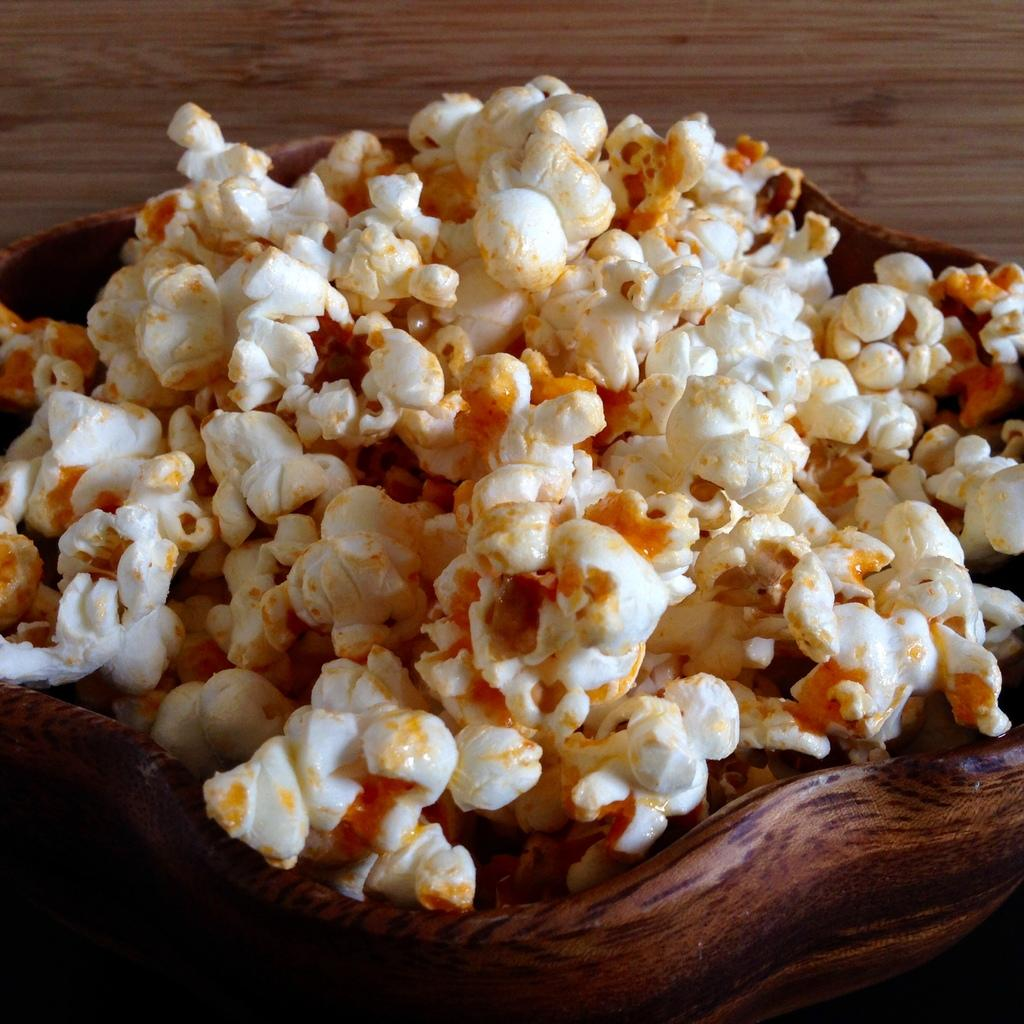What type of food is present in the image? There is popcorn in the image. What is the popcorn contained in? The popcorn is in a wooden bowl. Where is the wooden bowl placed? The wooden bowl is placed on a wooden plank. What type of banana is hanging from the coil in the image? There is no banana or coil present in the image; it only features popcorn in a wooden bowl placed on a wooden plank. 